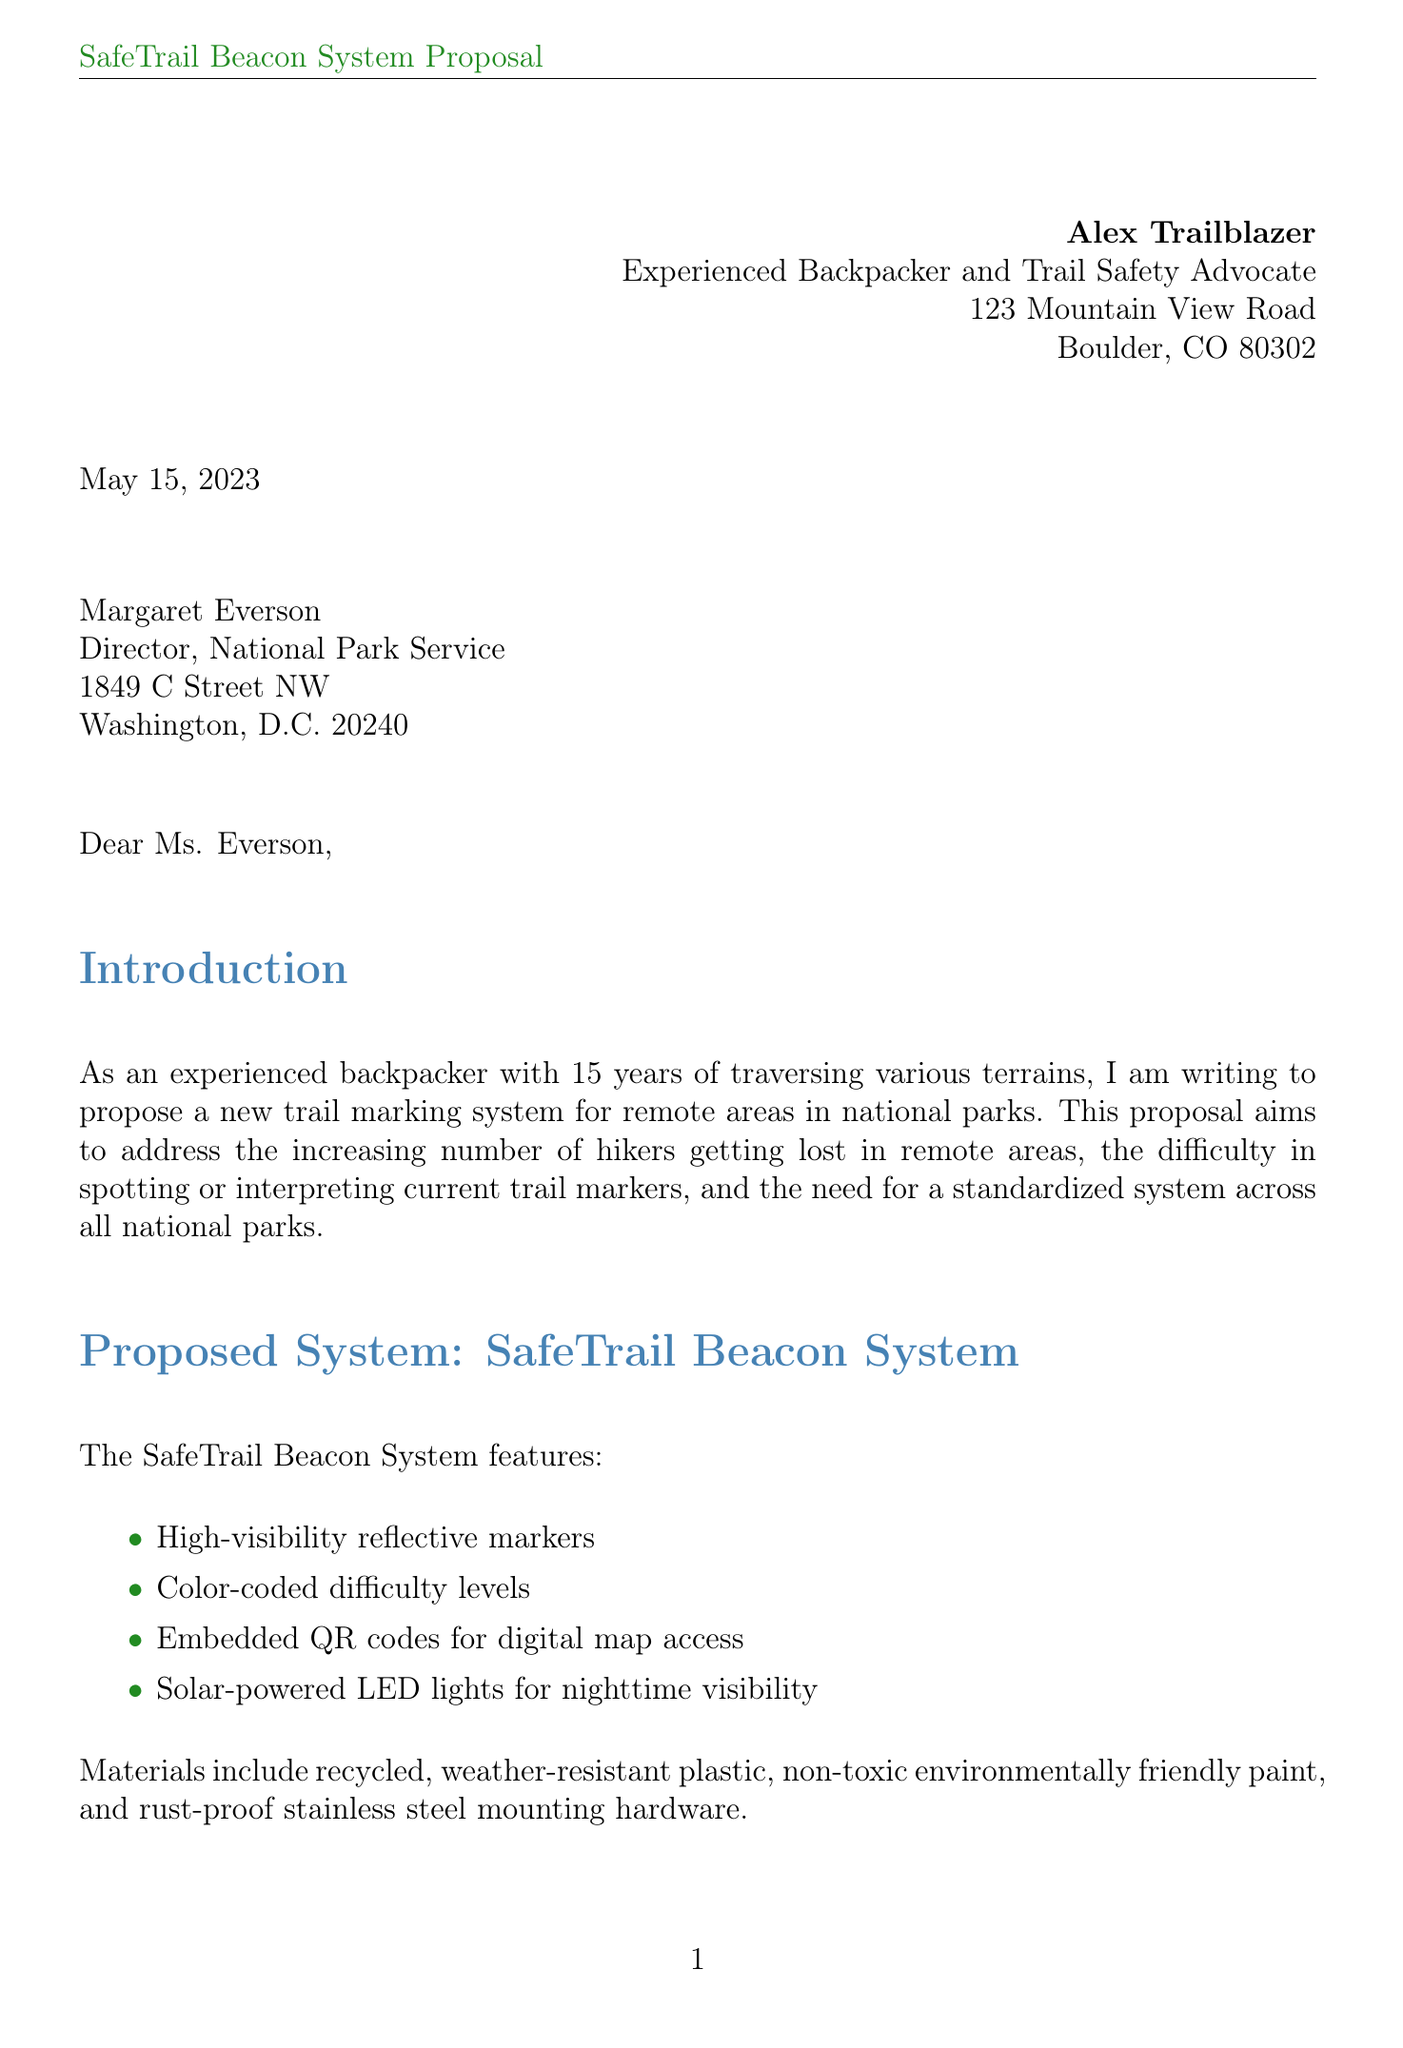What is the name of the proposed trail marking system? The proposed trail marking system is explicitly named in the document as the "SafeTrail Beacon System."
Answer: SafeTrail Beacon System Who is the recipient of the letter? The recipient's details are provided in the letter, specifically mentioning her name and title.
Answer: Margaret Everson What are the key features of the proposed system? The letter lists key features of the proposed system, including high-visibility reflective markers and color-coded difficulty levels.
Answer: High-visibility reflective markers, color-coded difficulty levels, embedded QR codes, solar-powered LED lights What is the duration of the pilot program? The pilot program duration is mentioned as part of the implementation plan in the letter.
Answer: 6 months What is the total cost estimate for full-scale implementation? The letter provides a financial breakdown, including the total amount for full implementation over two years.
Answer: $5,000,000 over 2 years How long is the evaluation phase? The document mentions the specific duration allocated for the evaluation and refinement of the proposed system.
Answer: 3 months What is the primary purpose of the letter? The introduction clearly states the main goal the author intends to achieve by writing this letter.
Answer: Propose a new trail marking system for remote areas in national parks What materials will be used for the markers? The letter specifies the types of materials planned for the construction of the markers.
Answer: Recycled, weather-resistant plastic; non-toxic paint; rust-proof stainless steel How many years is the full-scale implementation plan expected to take? The timeline for full-scale implementation is stated directly in the implementation plan section of the letter.
Answer: 2 years 